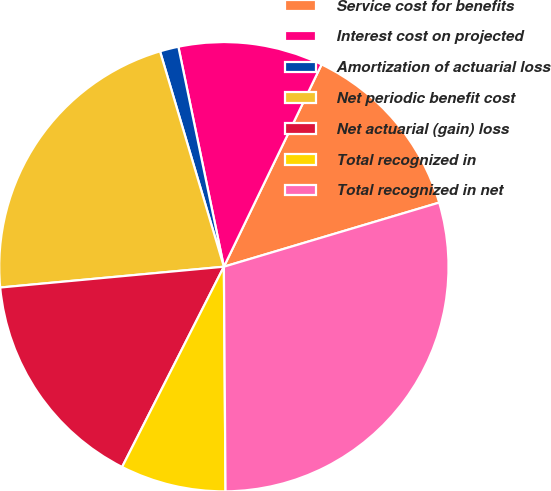<chart> <loc_0><loc_0><loc_500><loc_500><pie_chart><fcel>Service cost for benefits<fcel>Interest cost on projected<fcel>Amortization of actuarial loss<fcel>Net periodic benefit cost<fcel>Net actuarial (gain) loss<fcel>Total recognized in<fcel>Total recognized in net<nl><fcel>13.23%<fcel>10.41%<fcel>1.34%<fcel>21.89%<fcel>16.04%<fcel>7.6%<fcel>29.49%<nl></chart> 